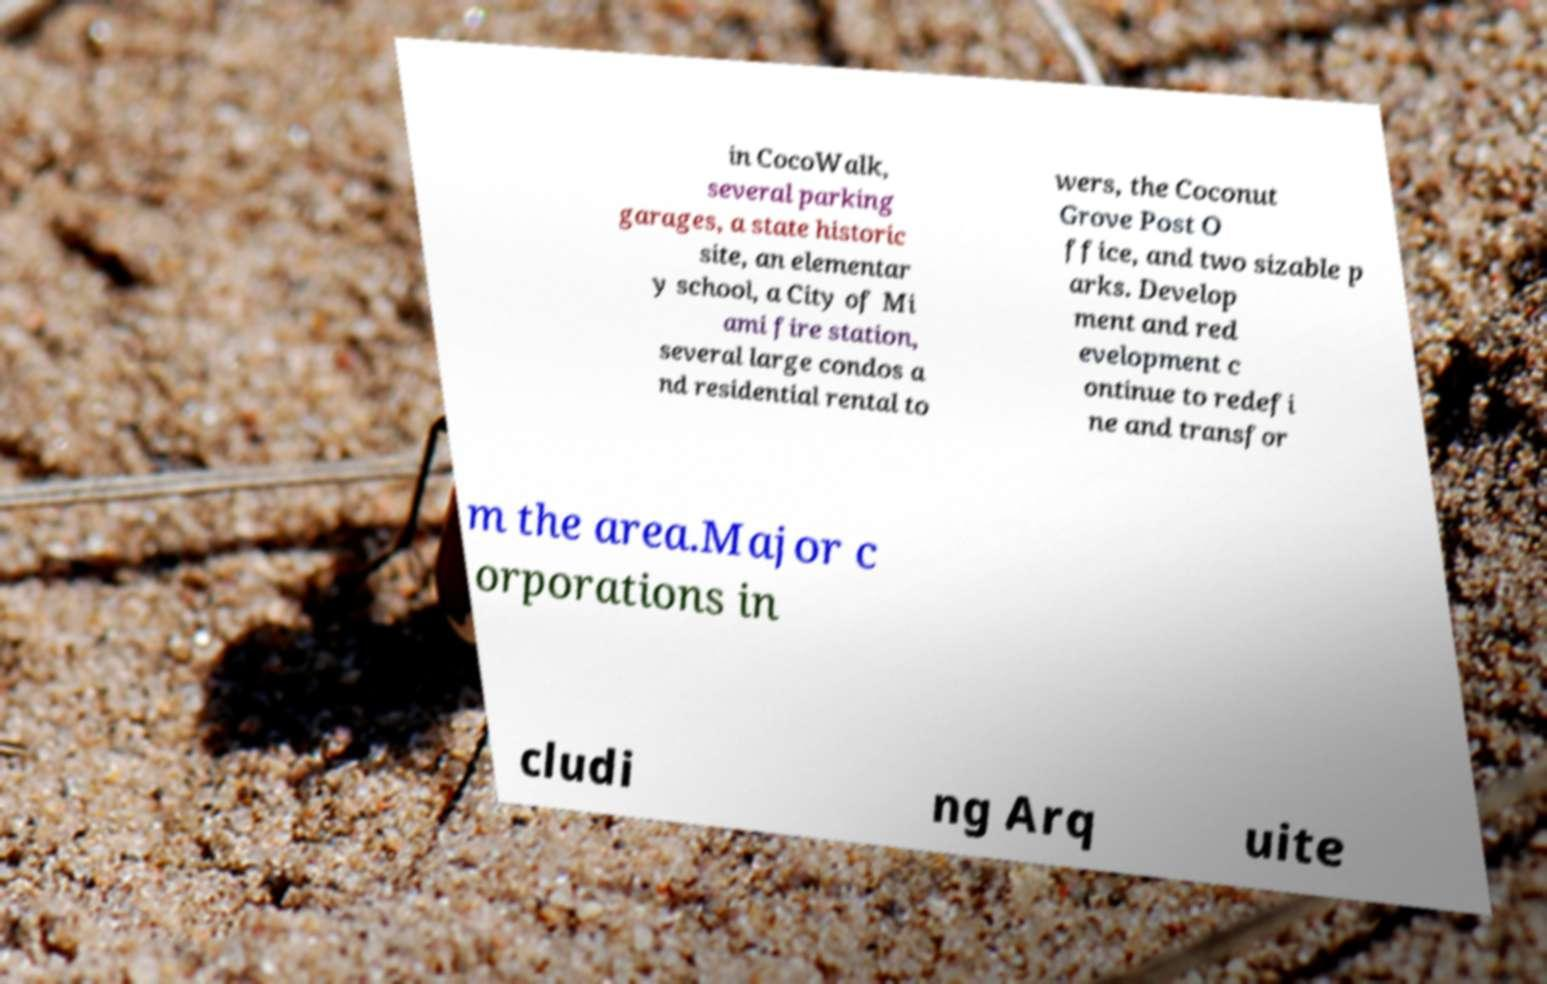Can you read and provide the text displayed in the image?This photo seems to have some interesting text. Can you extract and type it out for me? in CocoWalk, several parking garages, a state historic site, an elementar y school, a City of Mi ami fire station, several large condos a nd residential rental to wers, the Coconut Grove Post O ffice, and two sizable p arks. Develop ment and red evelopment c ontinue to redefi ne and transfor m the area.Major c orporations in cludi ng Arq uite 